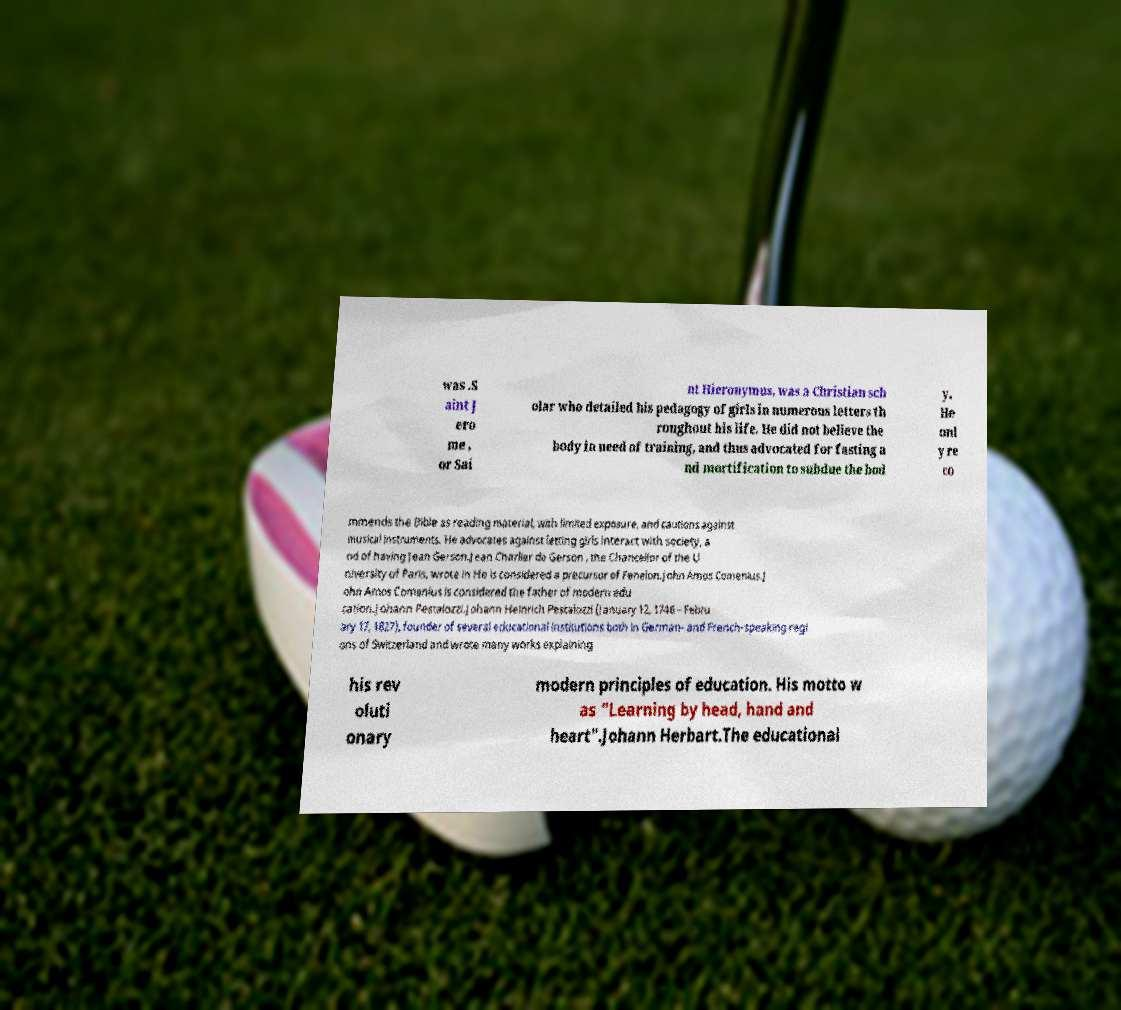Could you extract and type out the text from this image? was .S aint J ero me , or Sai nt Hieronymus, was a Christian sch olar who detailed his pedagogy of girls in numerous letters th roughout his life. He did not believe the body in need of training, and thus advocated for fasting a nd mortification to subdue the bod y. He onl y re co mmends the Bible as reading material, with limited exposure, and cautions against musical instruments. He advocates against letting girls interact with society, a nd of having Jean Gerson.Jean Charlier de Gerson , the Chancellor of the U niversity of Paris, wrote in He is considered a precursor of Fenelon.John Amos Comenius.J ohn Amos Comenius is considered the father of modern edu cation.Johann Pestalozzi.Johann Heinrich Pestalozzi (January 12, 1746 – Febru ary 17, 1827), founder of several educational institutions both in German- and French-speaking regi ons of Switzerland and wrote many works explaining his rev oluti onary modern principles of education. His motto w as "Learning by head, hand and heart".Johann Herbart.The educational 